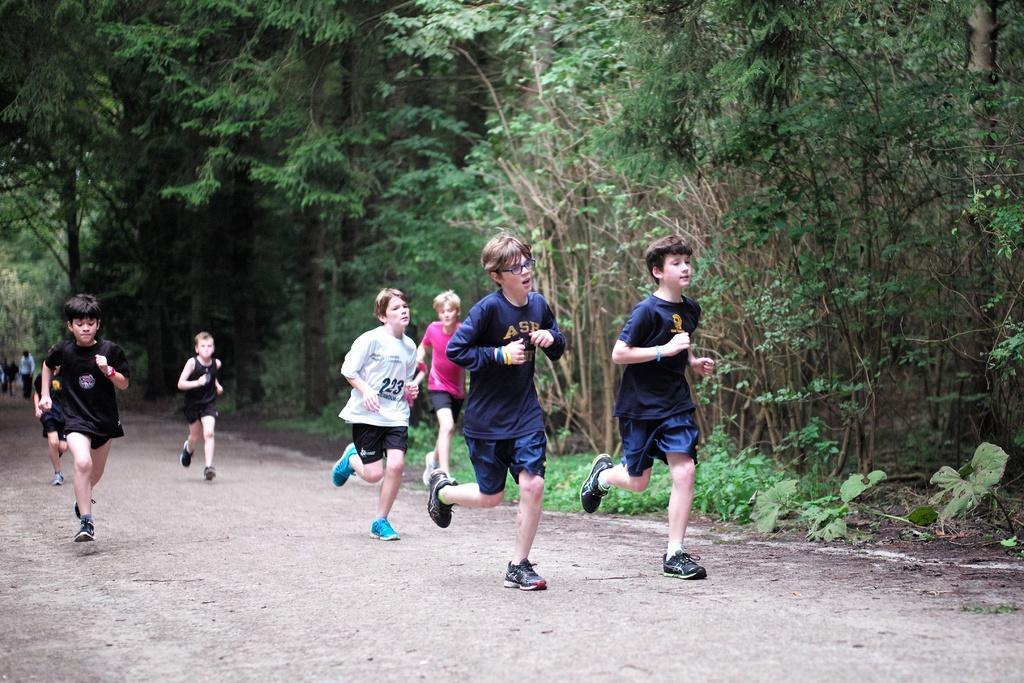In one or two sentences, can you explain what this image depicts? In this image we can see a group of children running on the road. On the backside we can see a group of trees and some plants. 